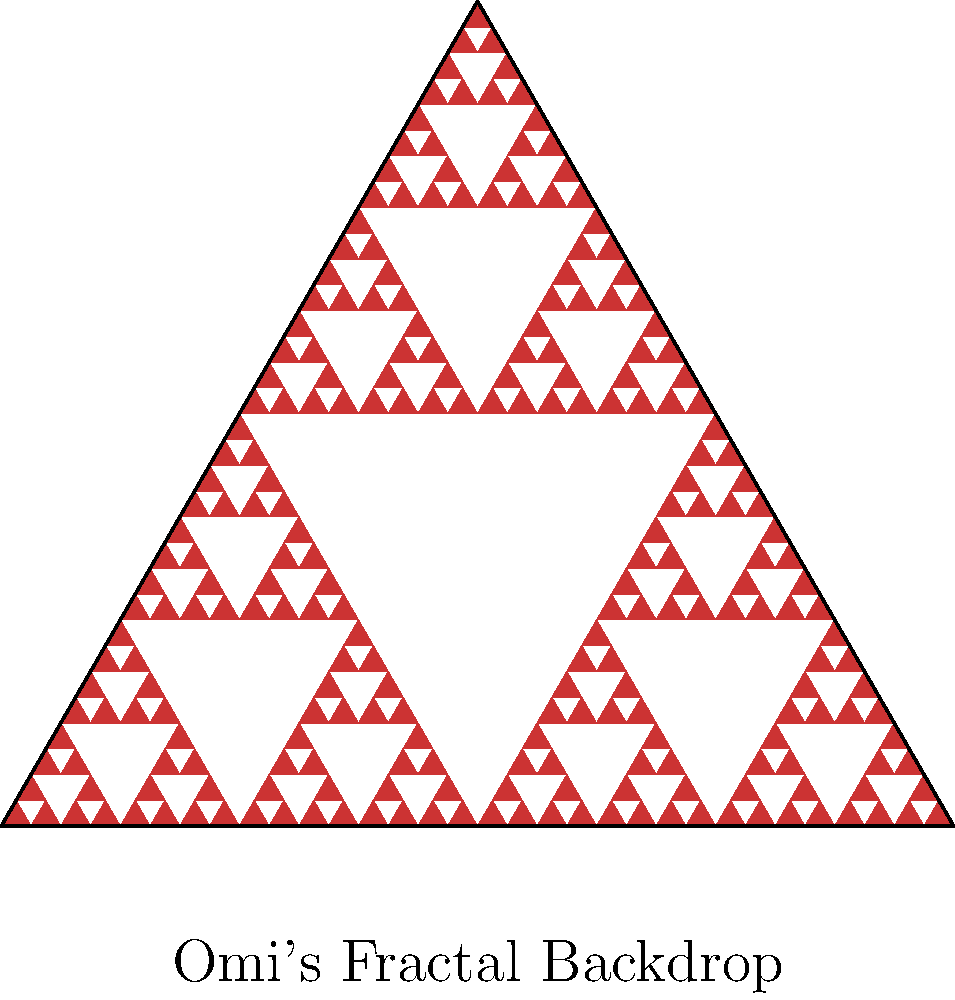In Omi's latest concert, his stage backdrop features a Sierpinski triangle fractal pattern. If the initial triangle has a side length of 1 meter, what is the total perimeter of all visible triangles after 5 iterations of the fractal? To solve this problem, let's break it down step-by-step:

1) First, we need to understand how the Sierpinski triangle is constructed:
   - Start with an equilateral triangle
   - Divide it into four smaller equilateral triangles
   - Remove the central triangle
   - Repeat the process for each remaining triangle

2) Let's calculate the number of triangles at each iteration:
   - Iteration 0: 1 triangle
   - Iteration 1: 3 triangles
   - Iteration 2: 9 triangles
   - Iteration 3: 27 triangles
   - Iteration 4: 81 triangles
   - Iteration 5: 243 triangles

3) Now, let's consider the side length of these triangles:
   - Iteration 0: 1 meter
   - Iteration 1: 1/2 meter
   - Iteration 2: 1/4 meter
   - Iteration 3: 1/8 meter
   - Iteration 4: 1/16 meter
   - Iteration 5: 1/32 meter

4) The perimeter of each triangle is 3 times its side length.

5) So, the total perimeter at iteration 5 is:
   $$(3 \times 1) + (3 \times 3 \times \frac{1}{2}) + (9 \times 3 \times \frac{1}{4}) + (27 \times 3 \times \frac{1}{8}) + (81 \times 3 \times \frac{1}{16}) + (243 \times 3 \times \frac{1}{32})$$

6) Simplifying:
   $$3 + 4.5 + 6.75 + 10.125 + 15.1875 + 22.78125 = 62.34375$$

Therefore, the total perimeter of all visible triangles after 5 iterations is 62.34375 meters.
Answer: 62.34375 meters 